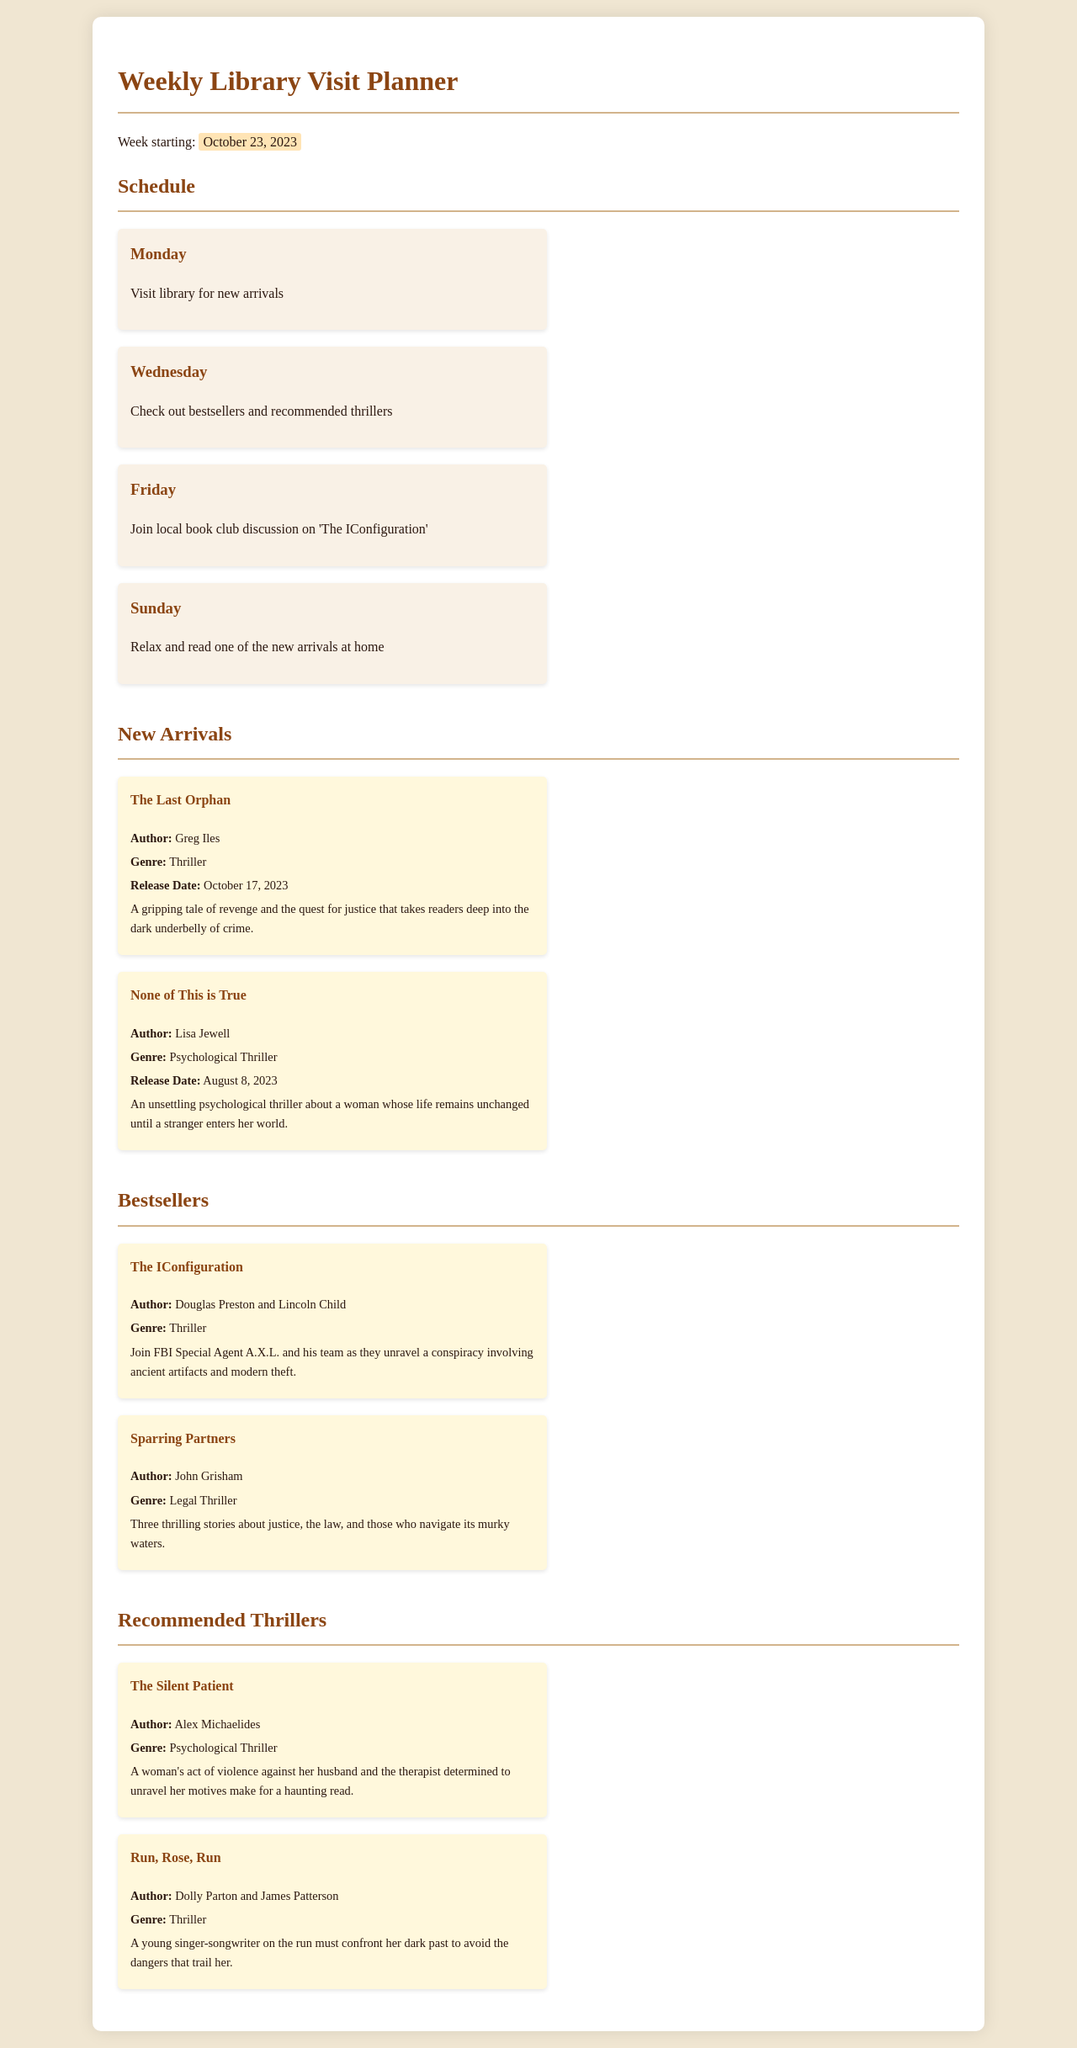What day is the library visit for new arrivals? New arrivals are scheduled to be checked out on Monday.
Answer: Monday Who is the author of "The IConfiguration"? The author of "The IConfiguration" is Douglas Preston and Lincoln Child.
Answer: Douglas Preston and Lincoln Child What genre is "None of This is True"? "None of This is True" falls under the genre of Psychological Thriller.
Answer: Psychological Thriller When is the book club discussion scheduled? The book club discussion is planned for Friday.
Answer: Friday What is the release date of "The Last Orphan"? "The Last Orphan" was released on October 17, 2023.
Answer: October 17, 2023 Which book is listed as a bestseller? "The IConfiguration" is listed as a bestseller.
Answer: The IConfiguration What type of thriller is "Run, Rose, Run"? "Run, Rose, Run" is classified as a Thriller.
Answer: Thriller What is the main activity planned for Sunday? The main activity for Sunday is to relax and read one of the new arrivals at home.
Answer: Relax and read one of the new arrivals at home How many new arrivals are listed? There are two new arrivals listed in the document.
Answer: Two 